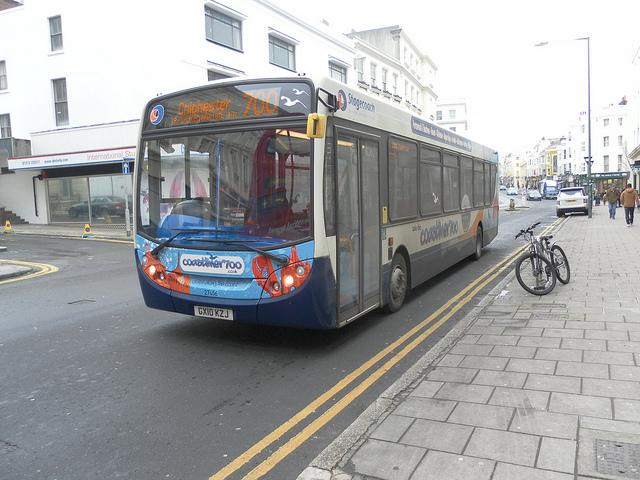Which vehicle has violated the law? Please explain your reasoning. white car. There is a white car in the background that has parked on top of the sidewalk which is a pedestrian zone. it is typically illegal to park a vehicle on the sidewalk which is intended for pedestrian use. 